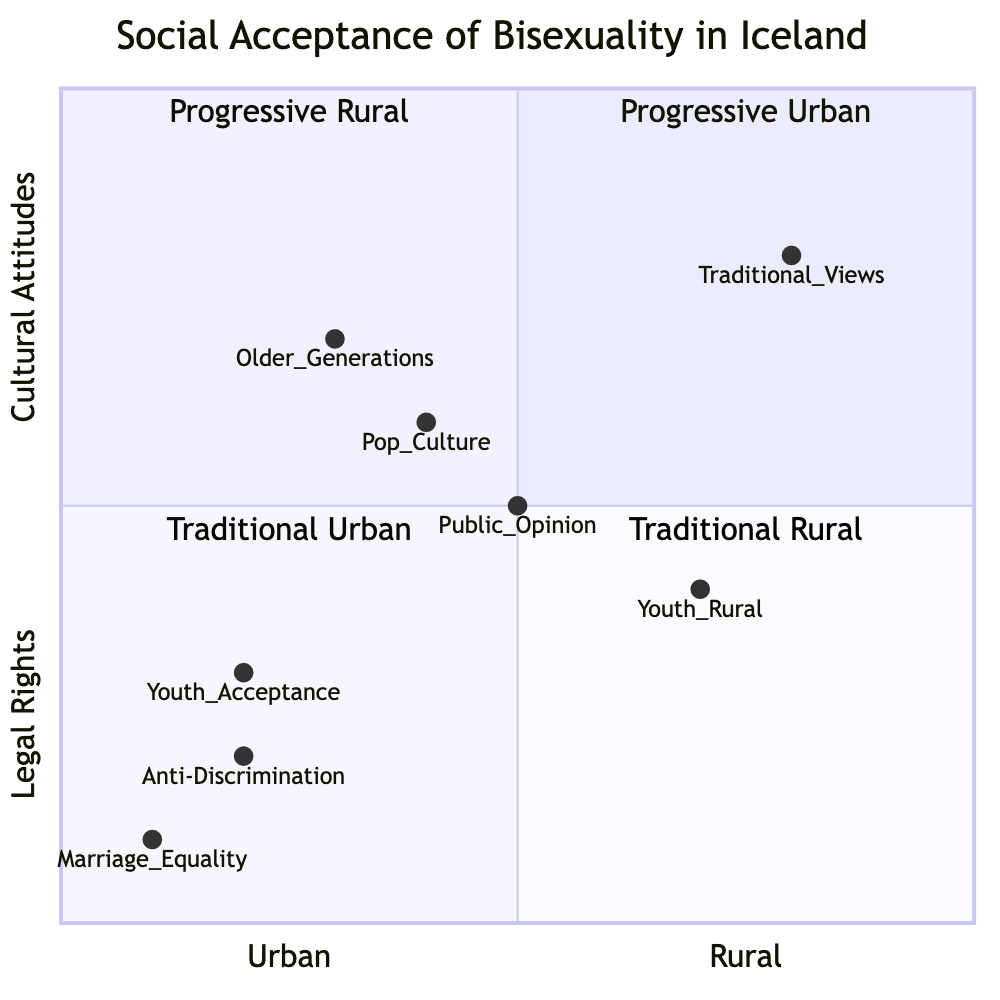What is the acceptance rate for youth in urban areas? The data shows that the acceptance rate for youth aged 18-25 in urban areas, specifically Reykjavik, is 85%.
Answer: 85% What is the acceptance rate for older generations in rural areas? According to the data, older generations in rural areas show a significantly lower acceptance rate of around 30%.
Answer: 30% What do robust anti-discrimination laws protect? The diagram indicates that robust anti-discrimination laws protect bisexual individuals in workplaces and public services.
Answer: Bisexual individuals Which group shows a higher acceptance rate: youth in urban areas or youth in rural areas? The youth acceptance rate in urban areas is 85%, while the youth perception rate in rural areas is 60%. Since 85% is greater than 60%, urban youth show higher acceptance.
Answer: Urban youth What does public opinion indicate about cultural attitudes in rural vs. urban settings? The diagram notes that public opinion shows visible gaps in cultural attitudes between rural and urban settings, with urban areas demonstrating a more progressive stance.
Answer: Gaps How does the general public's opinion evolve in Iceland regarding bisexuality? The cultural attitudes are evolving, with visible differences in acceptance noted in rural versus urban locations, highlighting that urban areas are generally more progressive in this regard.
Answer: Evolving In which quadrant would you place those who support marriage equality for bisexual individuals? Since the element marriage equality points to legal rights and fits within a progressive context, it would be placed in the "Progressive Urban" quadrant, indicating both legal rights and a support status rooted in urban acceptance.
Answer: Progressive Urban What cultural representation has increased in Icelandic media? The data indicates there has been increased positive representation of bisexual characters in popular media, like the show 'Trapped', which likely contributes to cultural attitudes.
Answer: Positive representation Which group has the highest level of acceptance overall? In comparing the acceptance rates, youth acceptance in urban areas (85%) is the highest, while older generations in rural areas (30%) represent the lowest. Thus, the youth in urban areas hold the highest acceptance level.
Answer: Youth in urban areas 